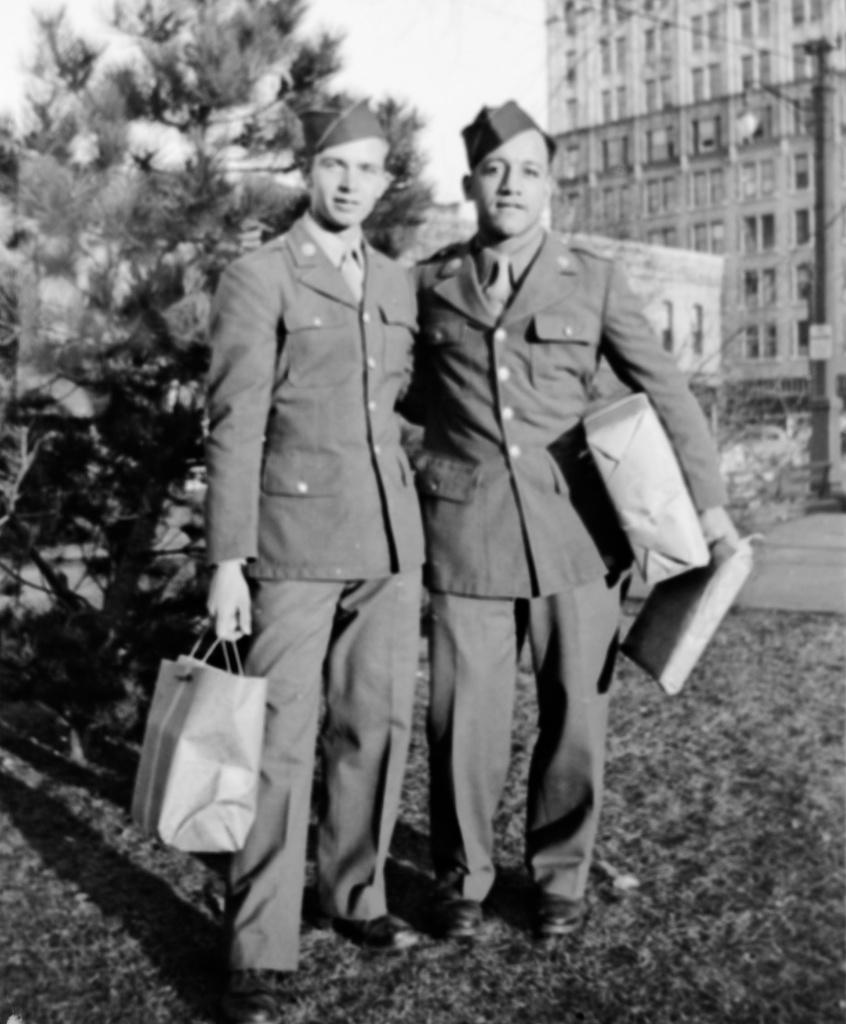In one or two sentences, can you explain what this image depicts? This is a black and white image in this image in the center there are two persons who are standing and they are holding some bags, in the background there is one tree and buildings. At the bottom there is grass. 